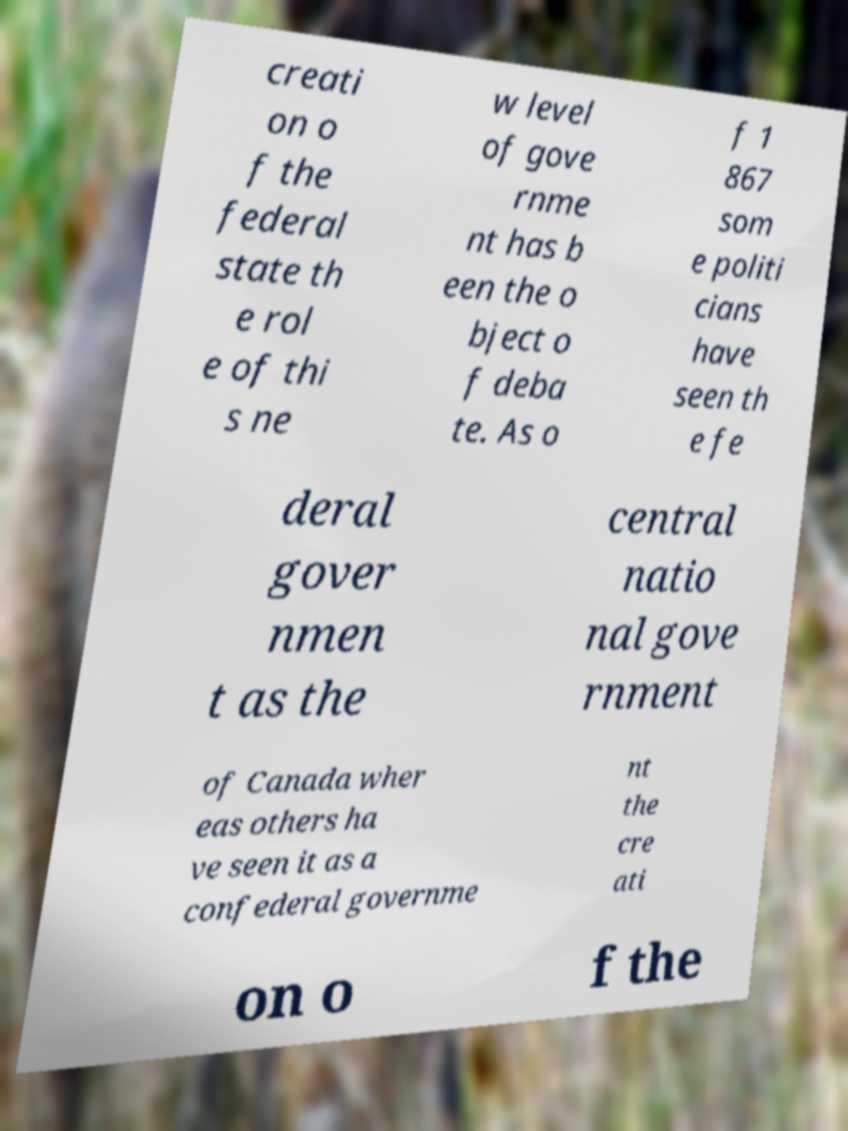Can you read and provide the text displayed in the image?This photo seems to have some interesting text. Can you extract and type it out for me? creati on o f the federal state th e rol e of thi s ne w level of gove rnme nt has b een the o bject o f deba te. As o f 1 867 som e politi cians have seen th e fe deral gover nmen t as the central natio nal gove rnment of Canada wher eas others ha ve seen it as a confederal governme nt the cre ati on o f the 